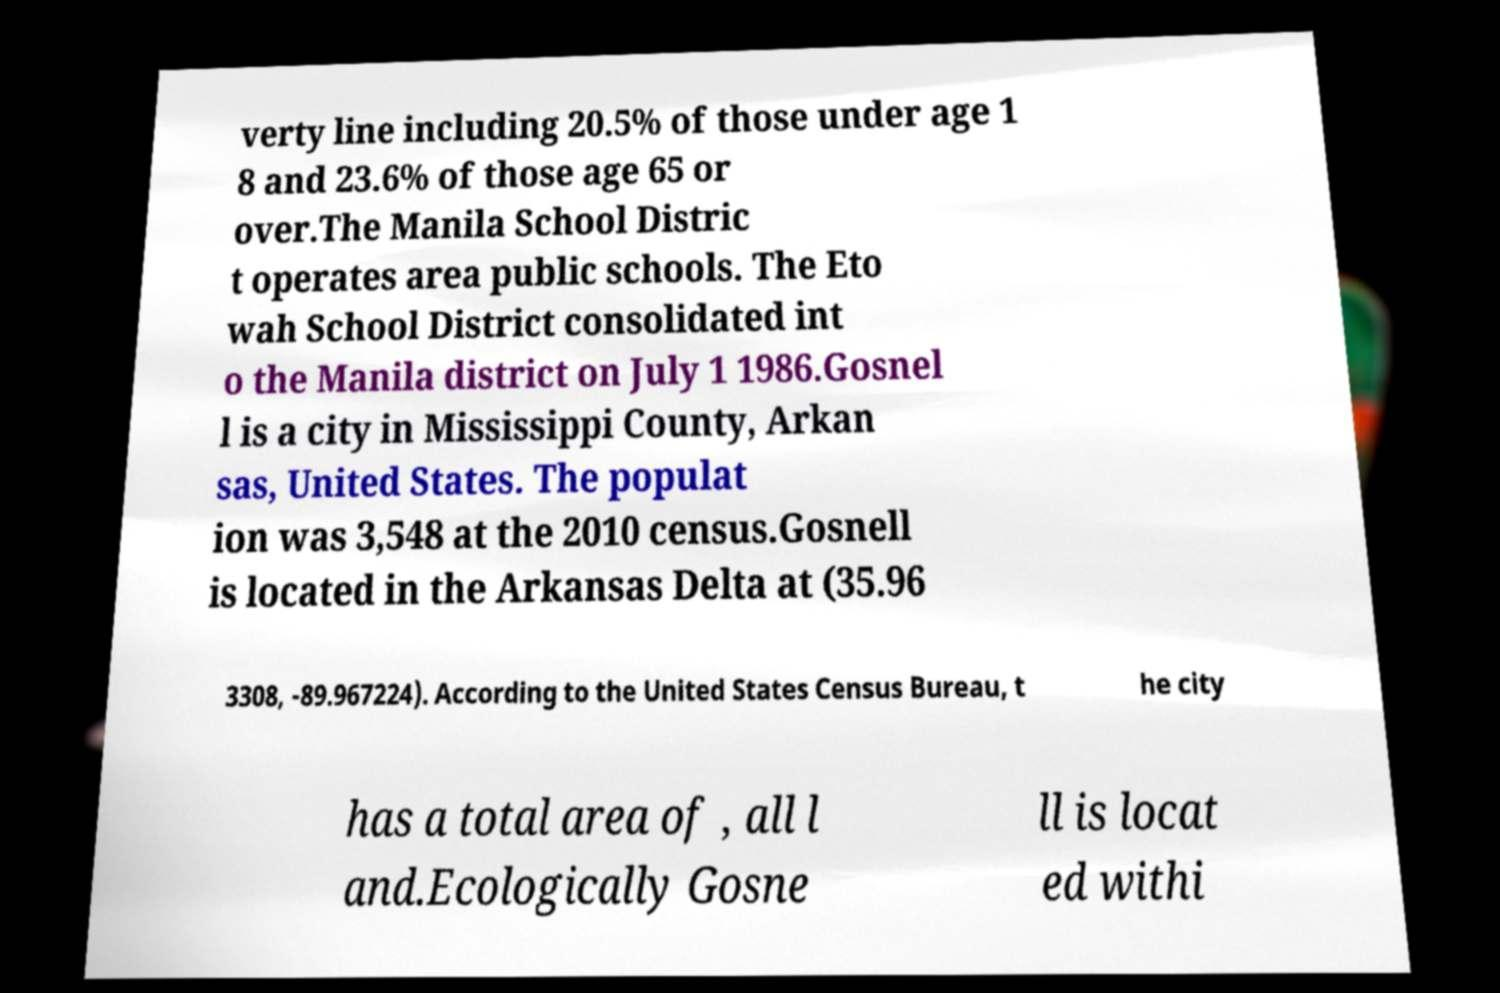Please read and relay the text visible in this image. What does it say? verty line including 20.5% of those under age 1 8 and 23.6% of those age 65 or over.The Manila School Distric t operates area public schools. The Eto wah School District consolidated int o the Manila district on July 1 1986.Gosnel l is a city in Mississippi County, Arkan sas, United States. The populat ion was 3,548 at the 2010 census.Gosnell is located in the Arkansas Delta at (35.96 3308, -89.967224). According to the United States Census Bureau, t he city has a total area of , all l and.Ecologically Gosne ll is locat ed withi 